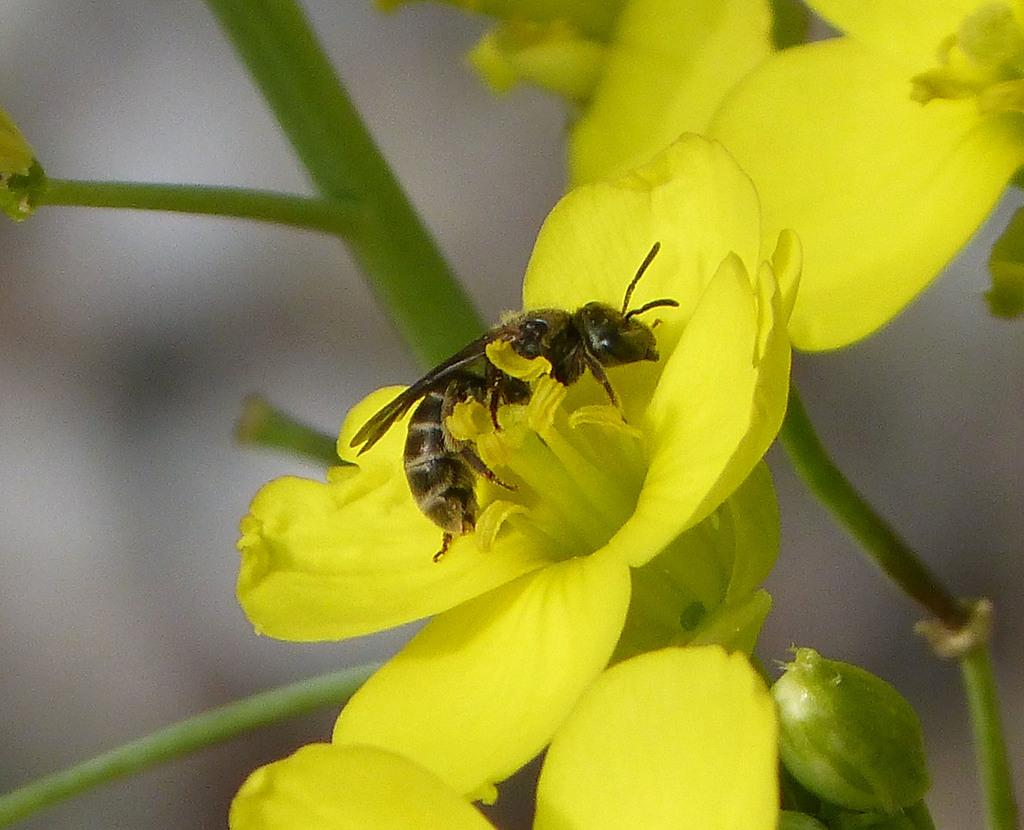What type of plant life is present in the image? There are flowers in the image. Can you describe the stage of growth of one of the flowers? There is a flower bud in the image, indicating that it is in the early stages of growth. What else can be seen in the image besides the flowers? There is a branch and an insect visible in the image. What type of pie is being served for breakfast in the image? There is no pie or breakfast scene present in the image; it features flowers, a flower bud, a branch, and an insect. 